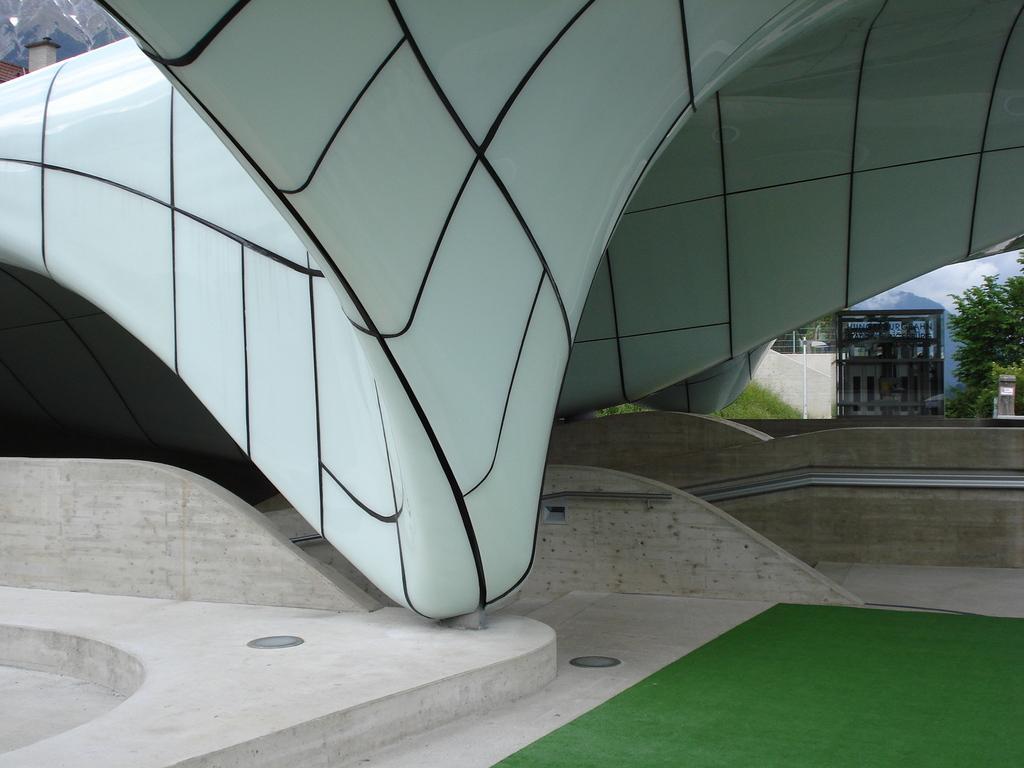Please provide a concise description of this image. In this image there is the sky, there is a building, there is a tree truncated towards the right of the image, there is the wall, there is a pole, there is grass, there is an object truncated towards the right of the image, there is an object on the ground, there is grass truncated towards the bottom of the image, there is a building truncated towards the left of the image. 